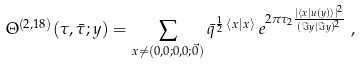Convert formula to latex. <formula><loc_0><loc_0><loc_500><loc_500>& \Theta ^ { ( 2 , 1 8 ) } ( \tau , \bar { \tau } ; y ) = \sum _ { x \neq ( 0 , 0 ; 0 , 0 ; \vec { 0 } ) } \bar { q } ^ { \frac { 1 } { 2 } \, \langle x | x \rangle } \, e ^ { 2 \pi \tau _ { 2 } \frac { | \langle x | u ( y ) \rangle | ^ { 2 } } { ( \Im y | \Im y ) ^ { 2 } } } \ ,</formula> 